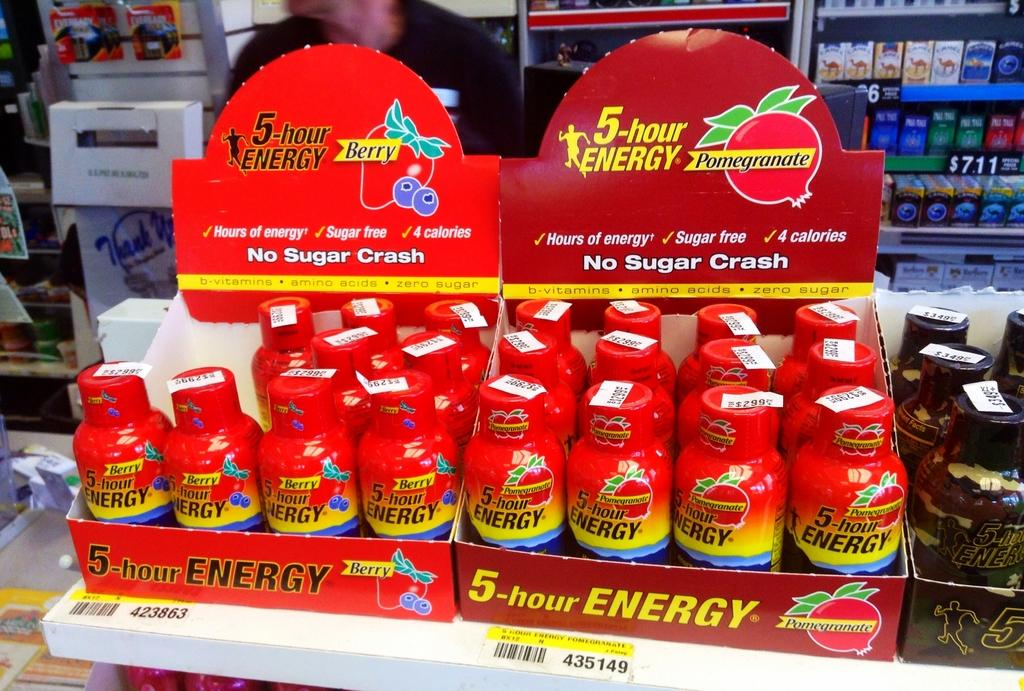<image>
Render a clear and concise summary of the photo. A display of 5 hour energy pomegranate and 5 hour energy berry. 